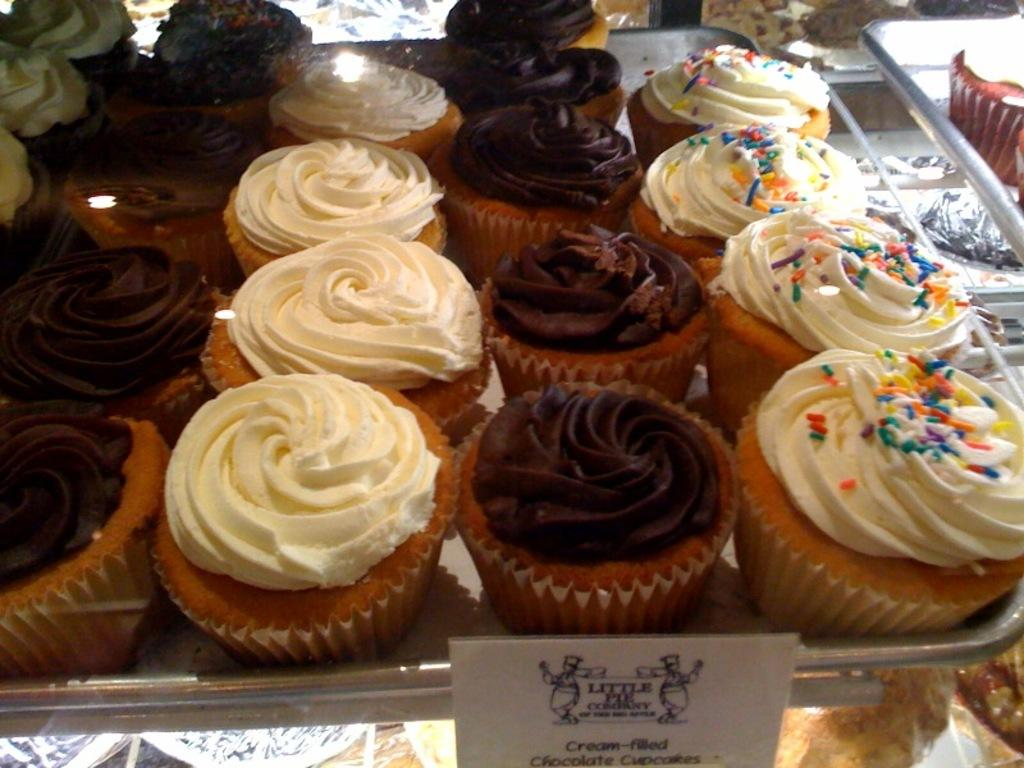What is on the tray that is visible in the image? There is a tray with cupcakes in the image. Can you describe the appearance of the cupcakes? The cupcakes are colorful. What else can be seen in the image besides the tray with cupcakes? There is a display board in the image. What is the reaction of the cupcakes when exposed to sunlight in the image? There is no indication in the image that the cupcakes are reacting to sunlight, as the image does not show any sunlight or the cupcakes' reaction to it. 